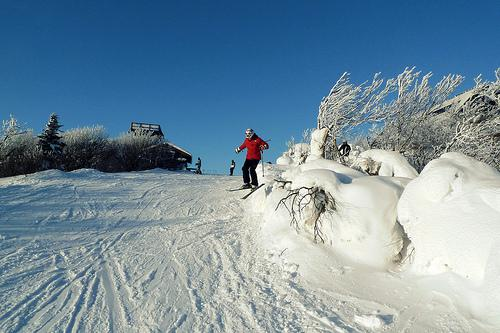Question: what is the weather like?
Choices:
A. Hot.
B. Rainy.
C. Cold.
D. Foggy.
Answer with the letter. Answer: C Question: when was picture taken?
Choices:
A. Fall.
B. Summer.
C. Spring.
D. Winter.
Answer with the letter. Answer: D Question: who is skiing?
Choices:
A. Person wearing blue.
B. Person wearing black.
C. Person in red shirt.
D. Person wearing orange.
Answer with the letter. Answer: C 